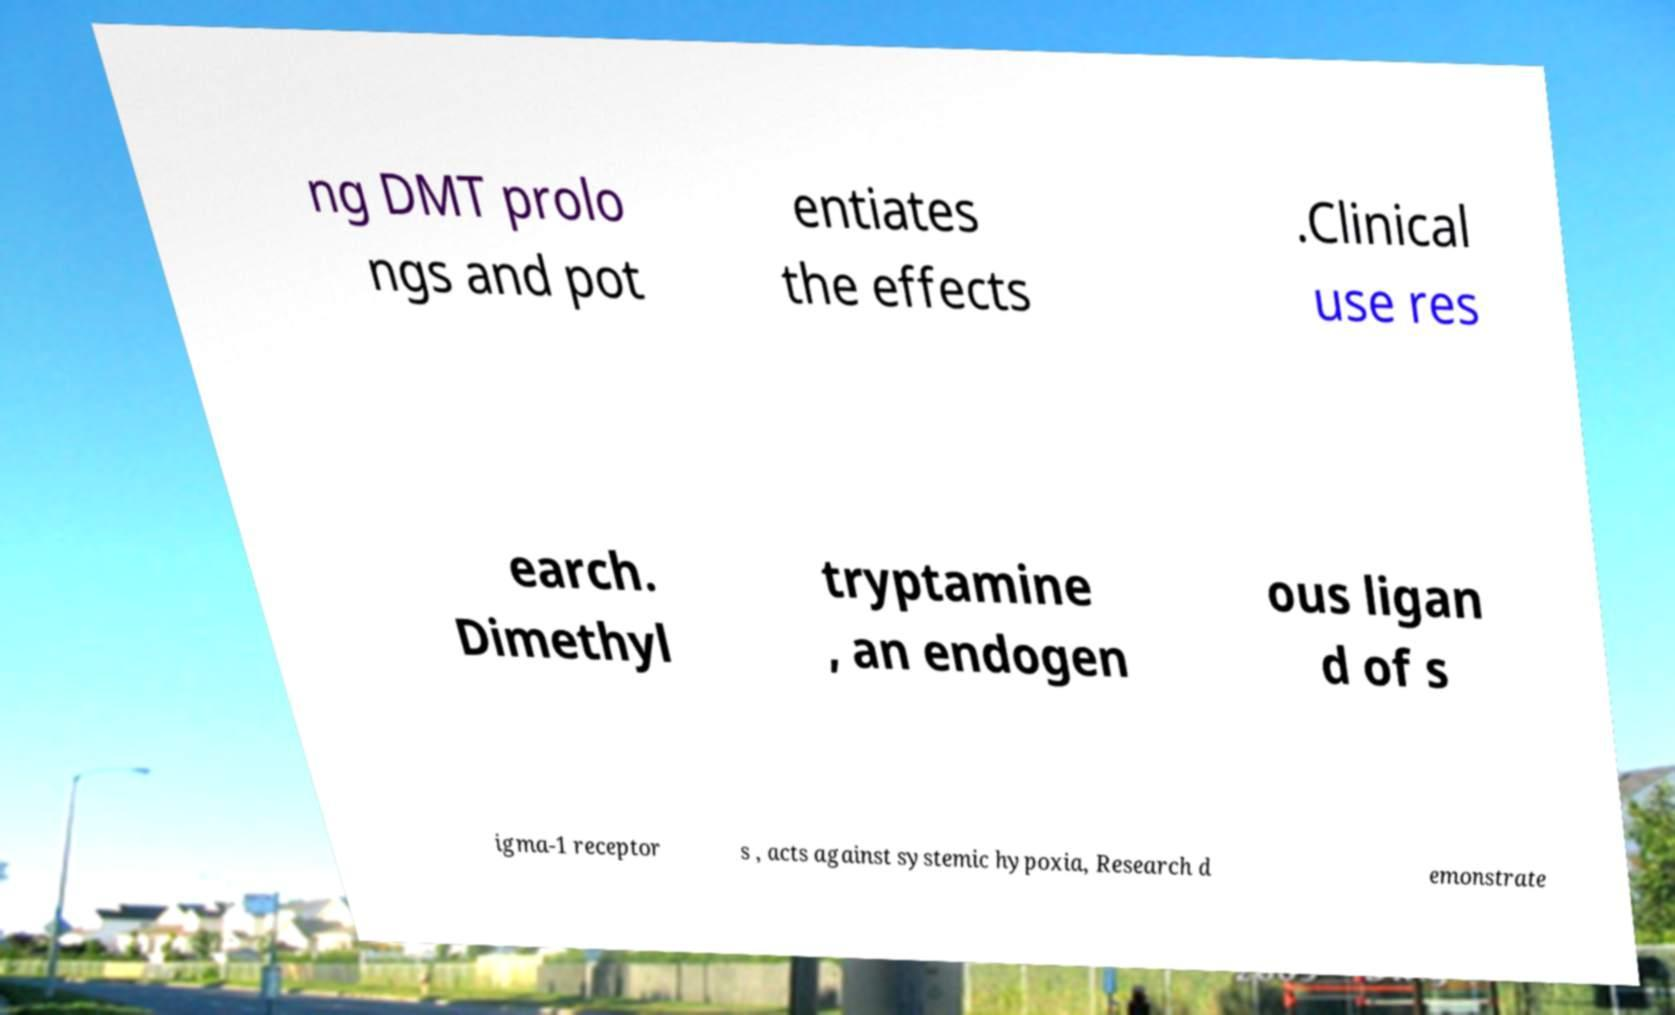I need the written content from this picture converted into text. Can you do that? ng DMT prolo ngs and pot entiates the effects .Clinical use res earch. Dimethyl tryptamine , an endogen ous ligan d of s igma-1 receptor s , acts against systemic hypoxia, Research d emonstrate 